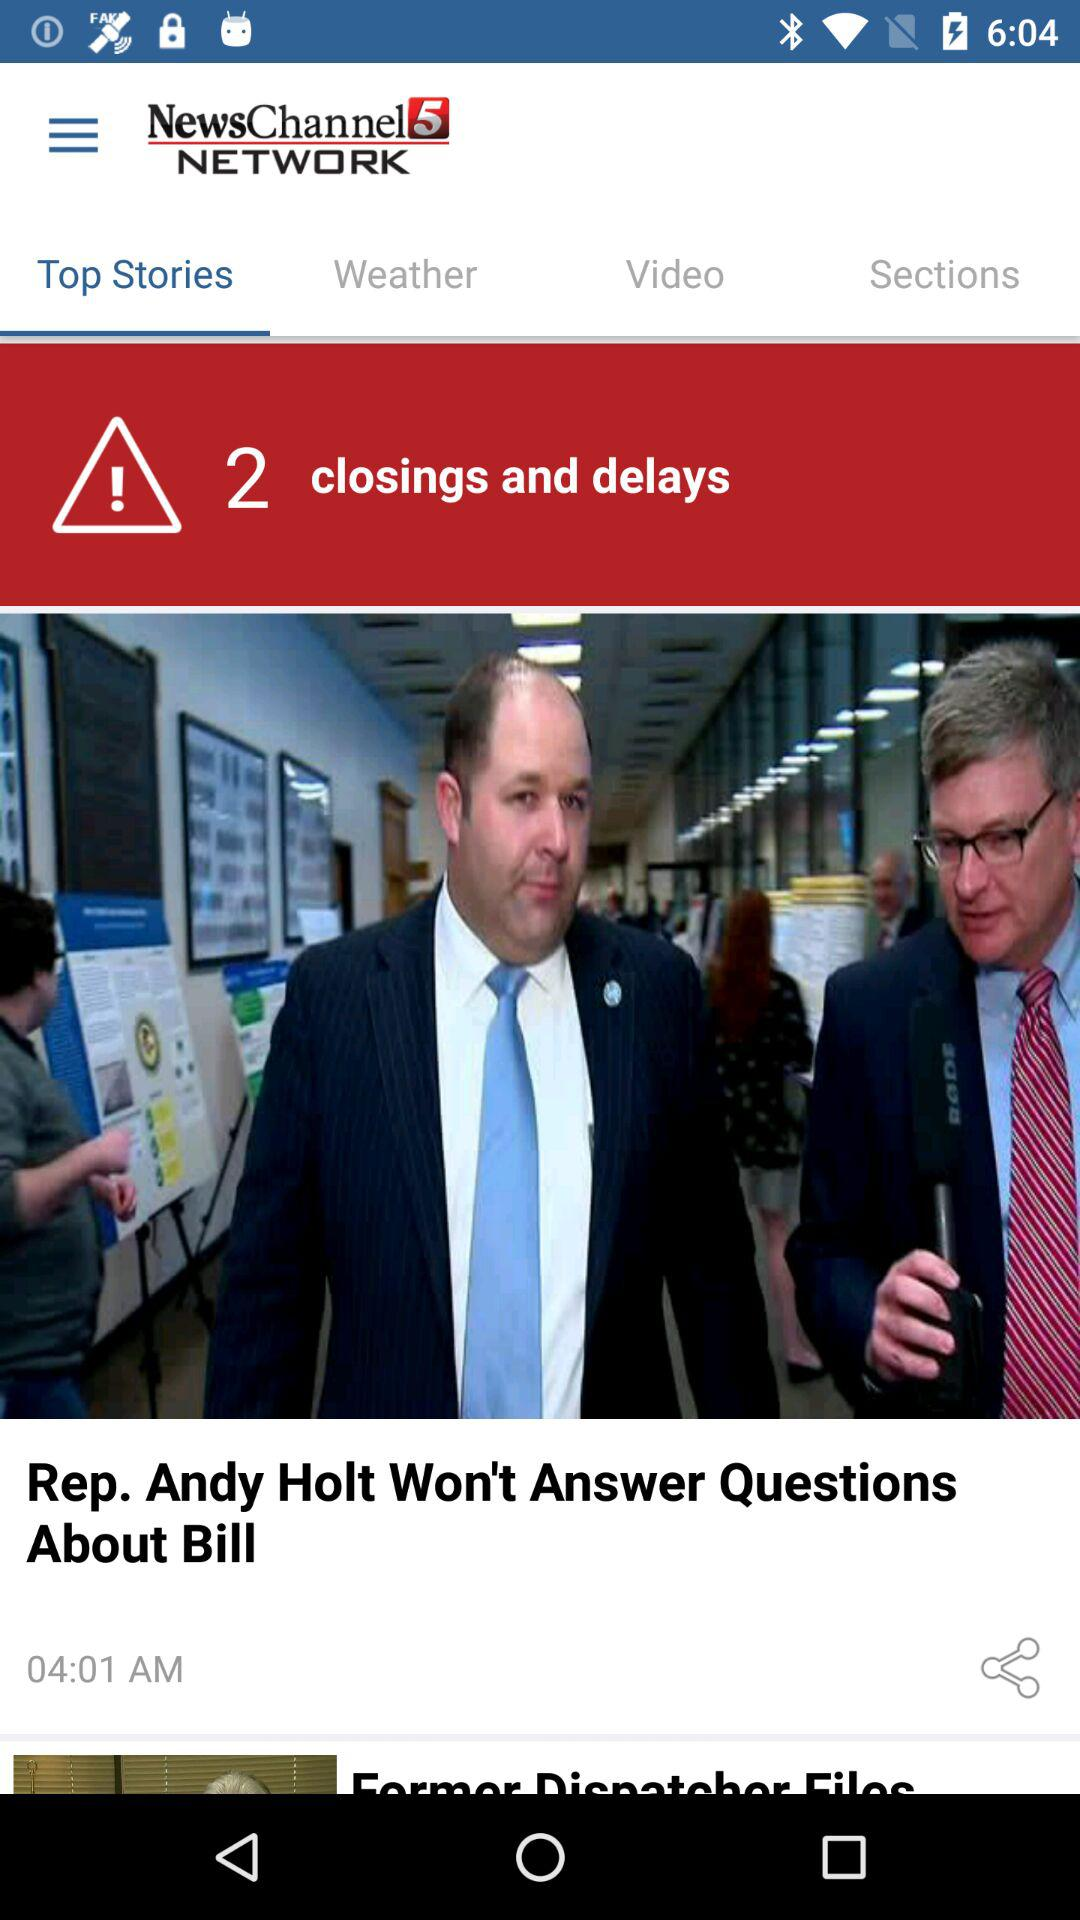What is the published time of the article? The published time of the article is 04:01 AM. 